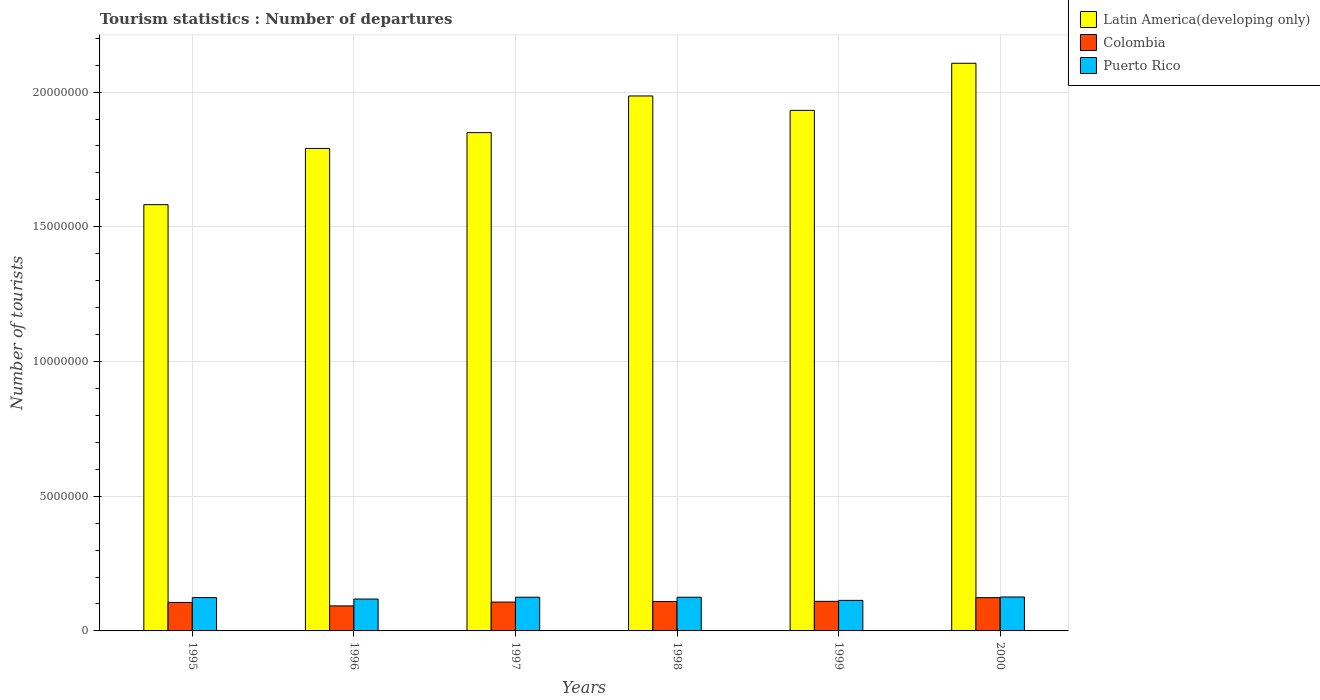How many different coloured bars are there?
Your answer should be very brief. 3. How many groups of bars are there?
Provide a short and direct response. 6. What is the label of the 6th group of bars from the left?
Make the answer very short. 2000. In how many cases, is the number of bars for a given year not equal to the number of legend labels?
Keep it short and to the point. 0. What is the number of tourist departures in Colombia in 1995?
Provide a short and direct response. 1.06e+06. Across all years, what is the maximum number of tourist departures in Colombia?
Your answer should be very brief. 1.24e+06. Across all years, what is the minimum number of tourist departures in Colombia?
Your answer should be very brief. 9.29e+05. In which year was the number of tourist departures in Puerto Rico minimum?
Make the answer very short. 1999. What is the total number of tourist departures in Puerto Rico in the graph?
Provide a short and direct response. 7.32e+06. What is the difference between the number of tourist departures in Puerto Rico in 1998 and that in 1999?
Your response must be concise. 1.16e+05. What is the difference between the number of tourist departures in Colombia in 2000 and the number of tourist departures in Puerto Rico in 1998?
Give a very brief answer. -1.50e+04. What is the average number of tourist departures in Latin America(developing only) per year?
Your answer should be very brief. 1.87e+07. In the year 1997, what is the difference between the number of tourist departures in Puerto Rico and number of tourist departures in Colombia?
Give a very brief answer. 1.80e+05. What is the ratio of the number of tourist departures in Latin America(developing only) in 1997 to that in 2000?
Provide a succinct answer. 0.88. What is the difference between the highest and the second highest number of tourist departures in Colombia?
Your response must be concise. 1.37e+05. What is the difference between the highest and the lowest number of tourist departures in Puerto Rico?
Your answer should be very brief. 1.25e+05. Is the sum of the number of tourist departures in Puerto Rico in 1995 and 1996 greater than the maximum number of tourist departures in Latin America(developing only) across all years?
Provide a short and direct response. No. What does the 3rd bar from the left in 1998 represents?
Provide a succinct answer. Puerto Rico. Is it the case that in every year, the sum of the number of tourist departures in Latin America(developing only) and number of tourist departures in Colombia is greater than the number of tourist departures in Puerto Rico?
Your response must be concise. Yes. How many bars are there?
Offer a terse response. 18. Are all the bars in the graph horizontal?
Your answer should be compact. No. How many years are there in the graph?
Keep it short and to the point. 6. What is the difference between two consecutive major ticks on the Y-axis?
Provide a short and direct response. 5.00e+06. Are the values on the major ticks of Y-axis written in scientific E-notation?
Make the answer very short. No. Does the graph contain any zero values?
Make the answer very short. No. Does the graph contain grids?
Provide a short and direct response. Yes. How are the legend labels stacked?
Your answer should be very brief. Vertical. What is the title of the graph?
Your response must be concise. Tourism statistics : Number of departures. Does "Puerto Rico" appear as one of the legend labels in the graph?
Ensure brevity in your answer.  Yes. What is the label or title of the Y-axis?
Your answer should be very brief. Number of tourists. What is the Number of tourists of Latin America(developing only) in 1995?
Make the answer very short. 1.58e+07. What is the Number of tourists in Colombia in 1995?
Ensure brevity in your answer.  1.06e+06. What is the Number of tourists of Puerto Rico in 1995?
Keep it short and to the point. 1.24e+06. What is the Number of tourists in Latin America(developing only) in 1996?
Provide a short and direct response. 1.79e+07. What is the Number of tourists of Colombia in 1996?
Provide a succinct answer. 9.29e+05. What is the Number of tourists in Puerto Rico in 1996?
Your response must be concise. 1.18e+06. What is the Number of tourists in Latin America(developing only) in 1997?
Give a very brief answer. 1.85e+07. What is the Number of tourists in Colombia in 1997?
Keep it short and to the point. 1.07e+06. What is the Number of tourists of Puerto Rico in 1997?
Ensure brevity in your answer.  1.25e+06. What is the Number of tourists in Latin America(developing only) in 1998?
Keep it short and to the point. 1.99e+07. What is the Number of tourists of Colombia in 1998?
Provide a succinct answer. 1.09e+06. What is the Number of tourists in Puerto Rico in 1998?
Provide a succinct answer. 1.25e+06. What is the Number of tourists of Latin America(developing only) in 1999?
Offer a very short reply. 1.93e+07. What is the Number of tourists of Colombia in 1999?
Your answer should be very brief. 1.10e+06. What is the Number of tourists of Puerto Rico in 1999?
Ensure brevity in your answer.  1.13e+06. What is the Number of tourists in Latin America(developing only) in 2000?
Provide a succinct answer. 2.11e+07. What is the Number of tourists of Colombia in 2000?
Your answer should be very brief. 1.24e+06. What is the Number of tourists of Puerto Rico in 2000?
Keep it short and to the point. 1.26e+06. Across all years, what is the maximum Number of tourists of Latin America(developing only)?
Keep it short and to the point. 2.11e+07. Across all years, what is the maximum Number of tourists of Colombia?
Offer a very short reply. 1.24e+06. Across all years, what is the maximum Number of tourists of Puerto Rico?
Your answer should be compact. 1.26e+06. Across all years, what is the minimum Number of tourists in Latin America(developing only)?
Provide a short and direct response. 1.58e+07. Across all years, what is the minimum Number of tourists of Colombia?
Your response must be concise. 9.29e+05. Across all years, what is the minimum Number of tourists of Puerto Rico?
Make the answer very short. 1.13e+06. What is the total Number of tourists in Latin America(developing only) in the graph?
Your answer should be very brief. 1.12e+08. What is the total Number of tourists of Colombia in the graph?
Your answer should be very brief. 6.48e+06. What is the total Number of tourists of Puerto Rico in the graph?
Offer a very short reply. 7.32e+06. What is the difference between the Number of tourists in Latin America(developing only) in 1995 and that in 1996?
Give a very brief answer. -2.09e+06. What is the difference between the Number of tourists of Colombia in 1995 and that in 1996?
Give a very brief answer. 1.28e+05. What is the difference between the Number of tourists of Puerto Rico in 1995 and that in 1996?
Offer a terse response. 5.30e+04. What is the difference between the Number of tourists in Latin America(developing only) in 1995 and that in 1997?
Make the answer very short. -2.67e+06. What is the difference between the Number of tourists in Colombia in 1995 and that in 1997?
Make the answer very short. -1.40e+04. What is the difference between the Number of tourists in Puerto Rico in 1995 and that in 1997?
Offer a very short reply. -1.40e+04. What is the difference between the Number of tourists in Latin America(developing only) in 1995 and that in 1998?
Make the answer very short. -4.03e+06. What is the difference between the Number of tourists of Colombia in 1995 and that in 1998?
Provide a succinct answer. -3.60e+04. What is the difference between the Number of tourists in Puerto Rico in 1995 and that in 1998?
Your answer should be compact. -1.30e+04. What is the difference between the Number of tourists in Latin America(developing only) in 1995 and that in 1999?
Make the answer very short. -3.50e+06. What is the difference between the Number of tourists in Colombia in 1995 and that in 1999?
Ensure brevity in your answer.  -4.10e+04. What is the difference between the Number of tourists of Puerto Rico in 1995 and that in 1999?
Your response must be concise. 1.03e+05. What is the difference between the Number of tourists in Latin America(developing only) in 1995 and that in 2000?
Make the answer very short. -5.25e+06. What is the difference between the Number of tourists of Colombia in 1995 and that in 2000?
Offer a very short reply. -1.78e+05. What is the difference between the Number of tourists of Puerto Rico in 1995 and that in 2000?
Give a very brief answer. -2.20e+04. What is the difference between the Number of tourists in Latin America(developing only) in 1996 and that in 1997?
Provide a short and direct response. -5.87e+05. What is the difference between the Number of tourists of Colombia in 1996 and that in 1997?
Your answer should be compact. -1.42e+05. What is the difference between the Number of tourists of Puerto Rico in 1996 and that in 1997?
Offer a terse response. -6.70e+04. What is the difference between the Number of tourists of Latin America(developing only) in 1996 and that in 1998?
Provide a succinct answer. -1.95e+06. What is the difference between the Number of tourists in Colombia in 1996 and that in 1998?
Ensure brevity in your answer.  -1.64e+05. What is the difference between the Number of tourists in Puerto Rico in 1996 and that in 1998?
Ensure brevity in your answer.  -6.60e+04. What is the difference between the Number of tourists of Latin America(developing only) in 1996 and that in 1999?
Make the answer very short. -1.41e+06. What is the difference between the Number of tourists in Colombia in 1996 and that in 1999?
Your answer should be compact. -1.69e+05. What is the difference between the Number of tourists in Puerto Rico in 1996 and that in 1999?
Provide a succinct answer. 5.00e+04. What is the difference between the Number of tourists of Latin America(developing only) in 1996 and that in 2000?
Give a very brief answer. -3.16e+06. What is the difference between the Number of tourists in Colombia in 1996 and that in 2000?
Your response must be concise. -3.06e+05. What is the difference between the Number of tourists of Puerto Rico in 1996 and that in 2000?
Offer a terse response. -7.50e+04. What is the difference between the Number of tourists in Latin America(developing only) in 1997 and that in 1998?
Provide a short and direct response. -1.36e+06. What is the difference between the Number of tourists of Colombia in 1997 and that in 1998?
Keep it short and to the point. -2.20e+04. What is the difference between the Number of tourists of Latin America(developing only) in 1997 and that in 1999?
Offer a terse response. -8.26e+05. What is the difference between the Number of tourists in Colombia in 1997 and that in 1999?
Keep it short and to the point. -2.70e+04. What is the difference between the Number of tourists of Puerto Rico in 1997 and that in 1999?
Offer a very short reply. 1.17e+05. What is the difference between the Number of tourists in Latin America(developing only) in 1997 and that in 2000?
Your answer should be very brief. -2.57e+06. What is the difference between the Number of tourists of Colombia in 1997 and that in 2000?
Keep it short and to the point. -1.64e+05. What is the difference between the Number of tourists in Puerto Rico in 1997 and that in 2000?
Provide a succinct answer. -8000. What is the difference between the Number of tourists of Latin America(developing only) in 1998 and that in 1999?
Keep it short and to the point. 5.35e+05. What is the difference between the Number of tourists of Colombia in 1998 and that in 1999?
Provide a short and direct response. -5000. What is the difference between the Number of tourists in Puerto Rico in 1998 and that in 1999?
Offer a terse response. 1.16e+05. What is the difference between the Number of tourists of Latin America(developing only) in 1998 and that in 2000?
Ensure brevity in your answer.  -1.21e+06. What is the difference between the Number of tourists in Colombia in 1998 and that in 2000?
Offer a very short reply. -1.42e+05. What is the difference between the Number of tourists of Puerto Rico in 1998 and that in 2000?
Keep it short and to the point. -9000. What is the difference between the Number of tourists of Latin America(developing only) in 1999 and that in 2000?
Provide a short and direct response. -1.75e+06. What is the difference between the Number of tourists in Colombia in 1999 and that in 2000?
Offer a very short reply. -1.37e+05. What is the difference between the Number of tourists in Puerto Rico in 1999 and that in 2000?
Ensure brevity in your answer.  -1.25e+05. What is the difference between the Number of tourists of Latin America(developing only) in 1995 and the Number of tourists of Colombia in 1996?
Provide a succinct answer. 1.49e+07. What is the difference between the Number of tourists in Latin America(developing only) in 1995 and the Number of tourists in Puerto Rico in 1996?
Keep it short and to the point. 1.46e+07. What is the difference between the Number of tourists in Colombia in 1995 and the Number of tourists in Puerto Rico in 1996?
Provide a succinct answer. -1.27e+05. What is the difference between the Number of tourists of Latin America(developing only) in 1995 and the Number of tourists of Colombia in 1997?
Give a very brief answer. 1.47e+07. What is the difference between the Number of tourists of Latin America(developing only) in 1995 and the Number of tourists of Puerto Rico in 1997?
Keep it short and to the point. 1.46e+07. What is the difference between the Number of tourists in Colombia in 1995 and the Number of tourists in Puerto Rico in 1997?
Keep it short and to the point. -1.94e+05. What is the difference between the Number of tourists of Latin America(developing only) in 1995 and the Number of tourists of Colombia in 1998?
Offer a terse response. 1.47e+07. What is the difference between the Number of tourists in Latin America(developing only) in 1995 and the Number of tourists in Puerto Rico in 1998?
Provide a succinct answer. 1.46e+07. What is the difference between the Number of tourists of Colombia in 1995 and the Number of tourists of Puerto Rico in 1998?
Your response must be concise. -1.93e+05. What is the difference between the Number of tourists in Latin America(developing only) in 1995 and the Number of tourists in Colombia in 1999?
Offer a terse response. 1.47e+07. What is the difference between the Number of tourists in Latin America(developing only) in 1995 and the Number of tourists in Puerto Rico in 1999?
Your answer should be very brief. 1.47e+07. What is the difference between the Number of tourists of Colombia in 1995 and the Number of tourists of Puerto Rico in 1999?
Offer a very short reply. -7.70e+04. What is the difference between the Number of tourists of Latin America(developing only) in 1995 and the Number of tourists of Colombia in 2000?
Your answer should be very brief. 1.46e+07. What is the difference between the Number of tourists of Latin America(developing only) in 1995 and the Number of tourists of Puerto Rico in 2000?
Offer a terse response. 1.46e+07. What is the difference between the Number of tourists of Colombia in 1995 and the Number of tourists of Puerto Rico in 2000?
Provide a succinct answer. -2.02e+05. What is the difference between the Number of tourists in Latin America(developing only) in 1996 and the Number of tourists in Colombia in 1997?
Provide a short and direct response. 1.68e+07. What is the difference between the Number of tourists of Latin America(developing only) in 1996 and the Number of tourists of Puerto Rico in 1997?
Give a very brief answer. 1.67e+07. What is the difference between the Number of tourists of Colombia in 1996 and the Number of tourists of Puerto Rico in 1997?
Provide a succinct answer. -3.22e+05. What is the difference between the Number of tourists of Latin America(developing only) in 1996 and the Number of tourists of Colombia in 1998?
Make the answer very short. 1.68e+07. What is the difference between the Number of tourists of Latin America(developing only) in 1996 and the Number of tourists of Puerto Rico in 1998?
Offer a very short reply. 1.67e+07. What is the difference between the Number of tourists in Colombia in 1996 and the Number of tourists in Puerto Rico in 1998?
Your response must be concise. -3.21e+05. What is the difference between the Number of tourists in Latin America(developing only) in 1996 and the Number of tourists in Colombia in 1999?
Offer a very short reply. 1.68e+07. What is the difference between the Number of tourists of Latin America(developing only) in 1996 and the Number of tourists of Puerto Rico in 1999?
Keep it short and to the point. 1.68e+07. What is the difference between the Number of tourists of Colombia in 1996 and the Number of tourists of Puerto Rico in 1999?
Your response must be concise. -2.05e+05. What is the difference between the Number of tourists in Latin America(developing only) in 1996 and the Number of tourists in Colombia in 2000?
Offer a terse response. 1.67e+07. What is the difference between the Number of tourists in Latin America(developing only) in 1996 and the Number of tourists in Puerto Rico in 2000?
Ensure brevity in your answer.  1.66e+07. What is the difference between the Number of tourists in Colombia in 1996 and the Number of tourists in Puerto Rico in 2000?
Your response must be concise. -3.30e+05. What is the difference between the Number of tourists of Latin America(developing only) in 1997 and the Number of tourists of Colombia in 1998?
Your answer should be compact. 1.74e+07. What is the difference between the Number of tourists in Latin America(developing only) in 1997 and the Number of tourists in Puerto Rico in 1998?
Ensure brevity in your answer.  1.72e+07. What is the difference between the Number of tourists in Colombia in 1997 and the Number of tourists in Puerto Rico in 1998?
Ensure brevity in your answer.  -1.79e+05. What is the difference between the Number of tourists of Latin America(developing only) in 1997 and the Number of tourists of Colombia in 1999?
Offer a terse response. 1.74e+07. What is the difference between the Number of tourists in Latin America(developing only) in 1997 and the Number of tourists in Puerto Rico in 1999?
Ensure brevity in your answer.  1.74e+07. What is the difference between the Number of tourists in Colombia in 1997 and the Number of tourists in Puerto Rico in 1999?
Provide a short and direct response. -6.30e+04. What is the difference between the Number of tourists of Latin America(developing only) in 1997 and the Number of tourists of Colombia in 2000?
Provide a succinct answer. 1.73e+07. What is the difference between the Number of tourists in Latin America(developing only) in 1997 and the Number of tourists in Puerto Rico in 2000?
Your answer should be compact. 1.72e+07. What is the difference between the Number of tourists of Colombia in 1997 and the Number of tourists of Puerto Rico in 2000?
Offer a very short reply. -1.88e+05. What is the difference between the Number of tourists of Latin America(developing only) in 1998 and the Number of tourists of Colombia in 1999?
Offer a terse response. 1.88e+07. What is the difference between the Number of tourists in Latin America(developing only) in 1998 and the Number of tourists in Puerto Rico in 1999?
Your answer should be compact. 1.87e+07. What is the difference between the Number of tourists in Colombia in 1998 and the Number of tourists in Puerto Rico in 1999?
Your response must be concise. -4.10e+04. What is the difference between the Number of tourists of Latin America(developing only) in 1998 and the Number of tourists of Colombia in 2000?
Provide a short and direct response. 1.86e+07. What is the difference between the Number of tourists of Latin America(developing only) in 1998 and the Number of tourists of Puerto Rico in 2000?
Offer a very short reply. 1.86e+07. What is the difference between the Number of tourists in Colombia in 1998 and the Number of tourists in Puerto Rico in 2000?
Provide a succinct answer. -1.66e+05. What is the difference between the Number of tourists of Latin America(developing only) in 1999 and the Number of tourists of Colombia in 2000?
Make the answer very short. 1.81e+07. What is the difference between the Number of tourists in Latin America(developing only) in 1999 and the Number of tourists in Puerto Rico in 2000?
Make the answer very short. 1.81e+07. What is the difference between the Number of tourists of Colombia in 1999 and the Number of tourists of Puerto Rico in 2000?
Provide a succinct answer. -1.61e+05. What is the average Number of tourists in Latin America(developing only) per year?
Your response must be concise. 1.87e+07. What is the average Number of tourists of Colombia per year?
Provide a short and direct response. 1.08e+06. What is the average Number of tourists in Puerto Rico per year?
Give a very brief answer. 1.22e+06. In the year 1995, what is the difference between the Number of tourists in Latin America(developing only) and Number of tourists in Colombia?
Provide a succinct answer. 1.48e+07. In the year 1995, what is the difference between the Number of tourists in Latin America(developing only) and Number of tourists in Puerto Rico?
Your answer should be compact. 1.46e+07. In the year 1995, what is the difference between the Number of tourists in Colombia and Number of tourists in Puerto Rico?
Offer a terse response. -1.80e+05. In the year 1996, what is the difference between the Number of tourists in Latin America(developing only) and Number of tourists in Colombia?
Give a very brief answer. 1.70e+07. In the year 1996, what is the difference between the Number of tourists of Latin America(developing only) and Number of tourists of Puerto Rico?
Your answer should be very brief. 1.67e+07. In the year 1996, what is the difference between the Number of tourists in Colombia and Number of tourists in Puerto Rico?
Offer a terse response. -2.55e+05. In the year 1997, what is the difference between the Number of tourists in Latin America(developing only) and Number of tourists in Colombia?
Offer a very short reply. 1.74e+07. In the year 1997, what is the difference between the Number of tourists in Latin America(developing only) and Number of tourists in Puerto Rico?
Provide a succinct answer. 1.72e+07. In the year 1998, what is the difference between the Number of tourists of Latin America(developing only) and Number of tourists of Colombia?
Offer a terse response. 1.88e+07. In the year 1998, what is the difference between the Number of tourists of Latin America(developing only) and Number of tourists of Puerto Rico?
Keep it short and to the point. 1.86e+07. In the year 1998, what is the difference between the Number of tourists in Colombia and Number of tourists in Puerto Rico?
Ensure brevity in your answer.  -1.57e+05. In the year 1999, what is the difference between the Number of tourists of Latin America(developing only) and Number of tourists of Colombia?
Your answer should be compact. 1.82e+07. In the year 1999, what is the difference between the Number of tourists of Latin America(developing only) and Number of tourists of Puerto Rico?
Give a very brief answer. 1.82e+07. In the year 1999, what is the difference between the Number of tourists of Colombia and Number of tourists of Puerto Rico?
Make the answer very short. -3.60e+04. In the year 2000, what is the difference between the Number of tourists of Latin America(developing only) and Number of tourists of Colombia?
Give a very brief answer. 1.98e+07. In the year 2000, what is the difference between the Number of tourists of Latin America(developing only) and Number of tourists of Puerto Rico?
Offer a very short reply. 1.98e+07. In the year 2000, what is the difference between the Number of tourists in Colombia and Number of tourists in Puerto Rico?
Your response must be concise. -2.40e+04. What is the ratio of the Number of tourists in Latin America(developing only) in 1995 to that in 1996?
Give a very brief answer. 0.88. What is the ratio of the Number of tourists of Colombia in 1995 to that in 1996?
Offer a very short reply. 1.14. What is the ratio of the Number of tourists in Puerto Rico in 1995 to that in 1996?
Ensure brevity in your answer.  1.04. What is the ratio of the Number of tourists of Latin America(developing only) in 1995 to that in 1997?
Provide a short and direct response. 0.86. What is the ratio of the Number of tourists in Colombia in 1995 to that in 1997?
Make the answer very short. 0.99. What is the ratio of the Number of tourists of Latin America(developing only) in 1995 to that in 1998?
Offer a terse response. 0.8. What is the ratio of the Number of tourists in Colombia in 1995 to that in 1998?
Give a very brief answer. 0.97. What is the ratio of the Number of tourists of Puerto Rico in 1995 to that in 1998?
Keep it short and to the point. 0.99. What is the ratio of the Number of tourists in Latin America(developing only) in 1995 to that in 1999?
Make the answer very short. 0.82. What is the ratio of the Number of tourists in Colombia in 1995 to that in 1999?
Keep it short and to the point. 0.96. What is the ratio of the Number of tourists of Puerto Rico in 1995 to that in 1999?
Keep it short and to the point. 1.09. What is the ratio of the Number of tourists in Latin America(developing only) in 1995 to that in 2000?
Provide a succinct answer. 0.75. What is the ratio of the Number of tourists of Colombia in 1995 to that in 2000?
Give a very brief answer. 0.86. What is the ratio of the Number of tourists in Puerto Rico in 1995 to that in 2000?
Ensure brevity in your answer.  0.98. What is the ratio of the Number of tourists in Latin America(developing only) in 1996 to that in 1997?
Give a very brief answer. 0.97. What is the ratio of the Number of tourists in Colombia in 1996 to that in 1997?
Offer a very short reply. 0.87. What is the ratio of the Number of tourists of Puerto Rico in 1996 to that in 1997?
Your answer should be compact. 0.95. What is the ratio of the Number of tourists in Latin America(developing only) in 1996 to that in 1998?
Ensure brevity in your answer.  0.9. What is the ratio of the Number of tourists in Colombia in 1996 to that in 1998?
Your answer should be very brief. 0.85. What is the ratio of the Number of tourists in Puerto Rico in 1996 to that in 1998?
Make the answer very short. 0.95. What is the ratio of the Number of tourists of Latin America(developing only) in 1996 to that in 1999?
Offer a terse response. 0.93. What is the ratio of the Number of tourists of Colombia in 1996 to that in 1999?
Your answer should be very brief. 0.85. What is the ratio of the Number of tourists in Puerto Rico in 1996 to that in 1999?
Provide a short and direct response. 1.04. What is the ratio of the Number of tourists in Colombia in 1996 to that in 2000?
Your response must be concise. 0.75. What is the ratio of the Number of tourists of Puerto Rico in 1996 to that in 2000?
Ensure brevity in your answer.  0.94. What is the ratio of the Number of tourists in Latin America(developing only) in 1997 to that in 1998?
Offer a terse response. 0.93. What is the ratio of the Number of tourists of Colombia in 1997 to that in 1998?
Keep it short and to the point. 0.98. What is the ratio of the Number of tourists in Puerto Rico in 1997 to that in 1998?
Give a very brief answer. 1. What is the ratio of the Number of tourists of Latin America(developing only) in 1997 to that in 1999?
Your response must be concise. 0.96. What is the ratio of the Number of tourists of Colombia in 1997 to that in 1999?
Make the answer very short. 0.98. What is the ratio of the Number of tourists in Puerto Rico in 1997 to that in 1999?
Give a very brief answer. 1.1. What is the ratio of the Number of tourists in Latin America(developing only) in 1997 to that in 2000?
Provide a succinct answer. 0.88. What is the ratio of the Number of tourists in Colombia in 1997 to that in 2000?
Provide a succinct answer. 0.87. What is the ratio of the Number of tourists in Latin America(developing only) in 1998 to that in 1999?
Your answer should be very brief. 1.03. What is the ratio of the Number of tourists in Colombia in 1998 to that in 1999?
Your answer should be very brief. 1. What is the ratio of the Number of tourists of Puerto Rico in 1998 to that in 1999?
Offer a very short reply. 1.1. What is the ratio of the Number of tourists in Latin America(developing only) in 1998 to that in 2000?
Offer a very short reply. 0.94. What is the ratio of the Number of tourists in Colombia in 1998 to that in 2000?
Your response must be concise. 0.89. What is the ratio of the Number of tourists in Latin America(developing only) in 1999 to that in 2000?
Give a very brief answer. 0.92. What is the ratio of the Number of tourists of Colombia in 1999 to that in 2000?
Your answer should be very brief. 0.89. What is the ratio of the Number of tourists of Puerto Rico in 1999 to that in 2000?
Your answer should be compact. 0.9. What is the difference between the highest and the second highest Number of tourists of Latin America(developing only)?
Your response must be concise. 1.21e+06. What is the difference between the highest and the second highest Number of tourists of Colombia?
Provide a short and direct response. 1.37e+05. What is the difference between the highest and the second highest Number of tourists in Puerto Rico?
Your response must be concise. 8000. What is the difference between the highest and the lowest Number of tourists in Latin America(developing only)?
Keep it short and to the point. 5.25e+06. What is the difference between the highest and the lowest Number of tourists in Colombia?
Your answer should be very brief. 3.06e+05. What is the difference between the highest and the lowest Number of tourists in Puerto Rico?
Keep it short and to the point. 1.25e+05. 